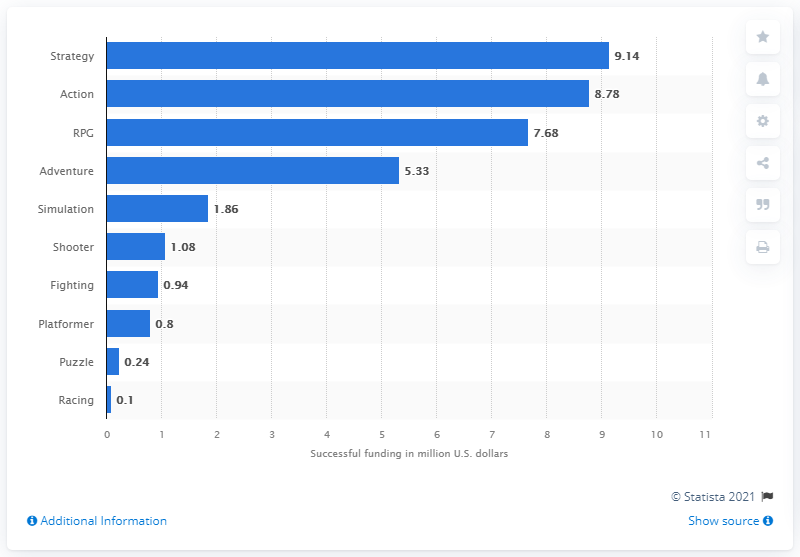Mention a couple of crucial points in this snapshot. Action games raised a total of $8,780,000 through successful Kickstarter and Indiegogo campaigns between June 2013 and May 2014. 